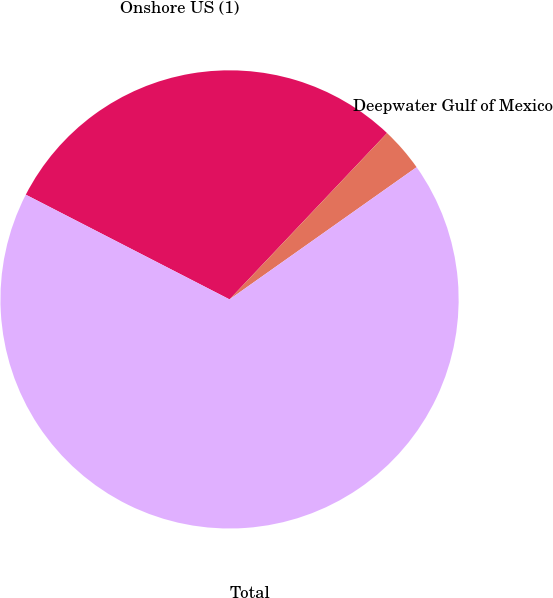<chart> <loc_0><loc_0><loc_500><loc_500><pie_chart><fcel>Onshore US (1)<fcel>Deepwater Gulf of Mexico<fcel>Total<nl><fcel>29.51%<fcel>3.14%<fcel>67.35%<nl></chart> 